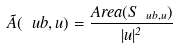Convert formula to latex. <formula><loc_0><loc_0><loc_500><loc_500>\tilde { A } ( \ u b , u ) = \frac { A r e a ( S _ { \ u b , u } ) } { | u | ^ { 2 } }</formula> 